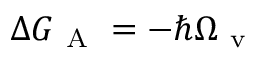Convert formula to latex. <formula><loc_0><loc_0><loc_500><loc_500>\Delta G _ { A } = - \hbar { \Omega } _ { v }</formula> 